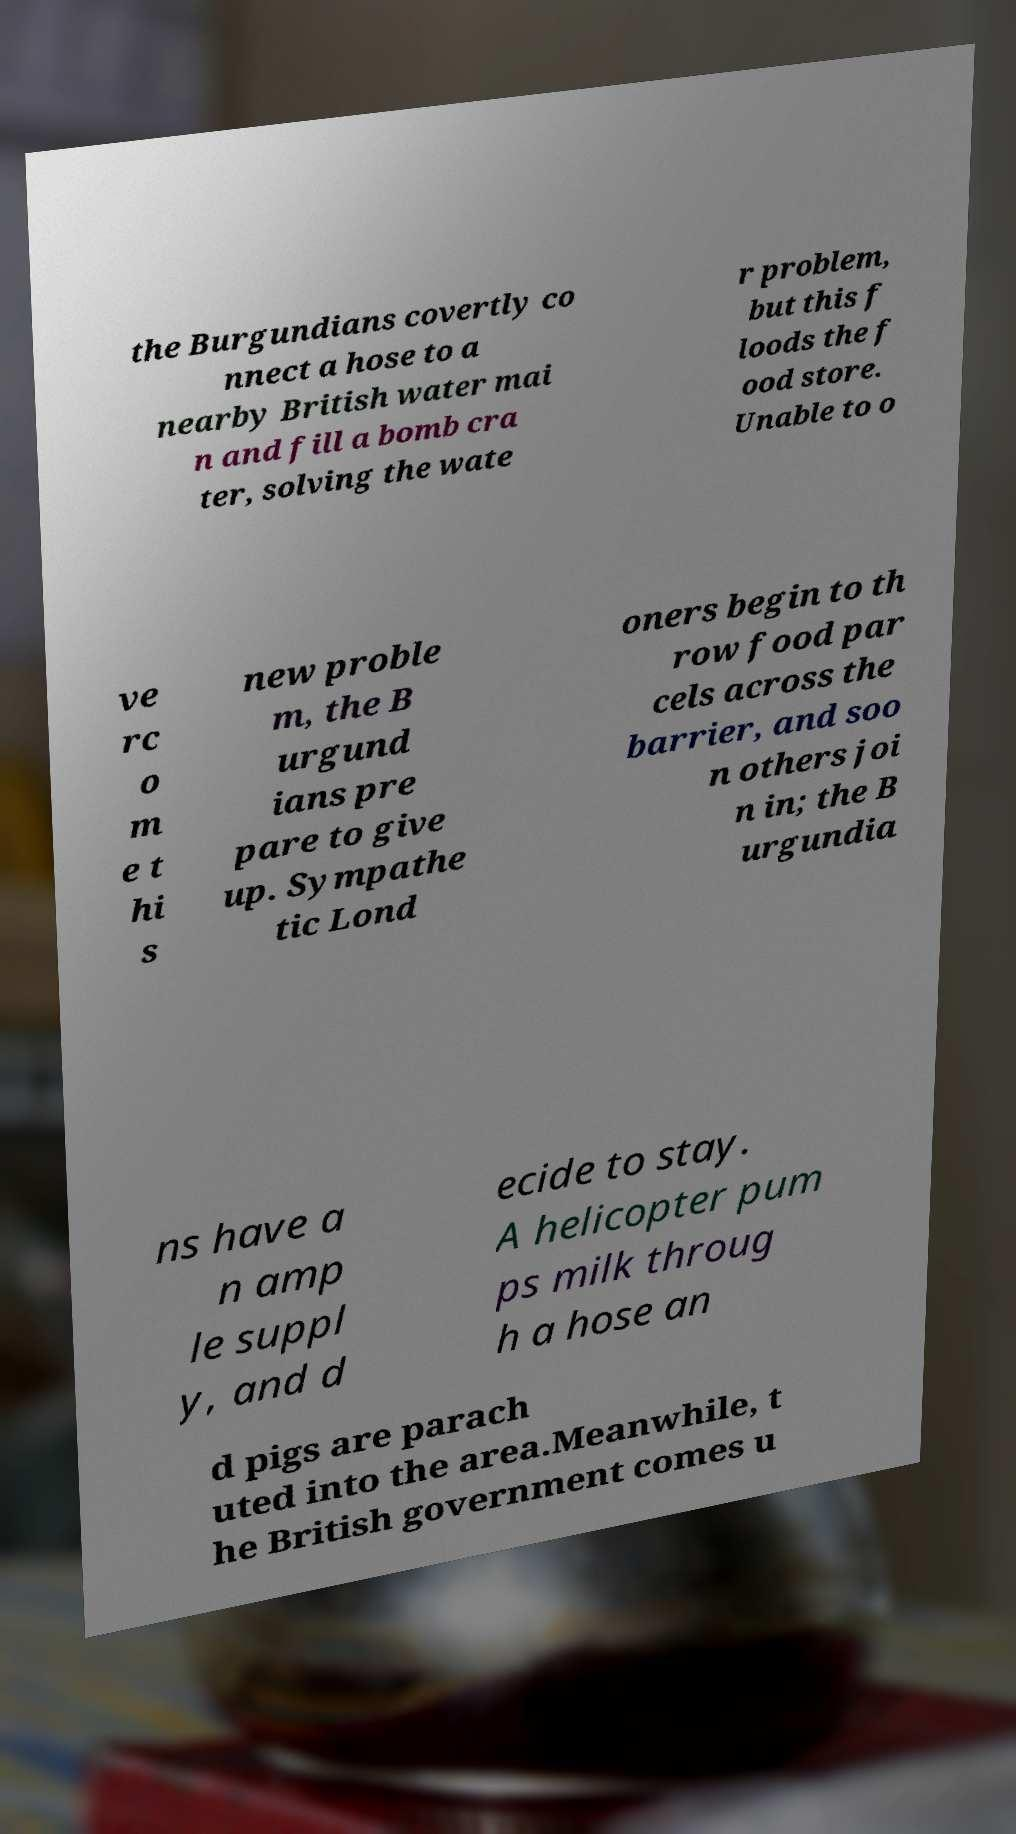Can you accurately transcribe the text from the provided image for me? the Burgundians covertly co nnect a hose to a nearby British water mai n and fill a bomb cra ter, solving the wate r problem, but this f loods the f ood store. Unable to o ve rc o m e t hi s new proble m, the B urgund ians pre pare to give up. Sympathe tic Lond oners begin to th row food par cels across the barrier, and soo n others joi n in; the B urgundia ns have a n amp le suppl y, and d ecide to stay. A helicopter pum ps milk throug h a hose an d pigs are parach uted into the area.Meanwhile, t he British government comes u 